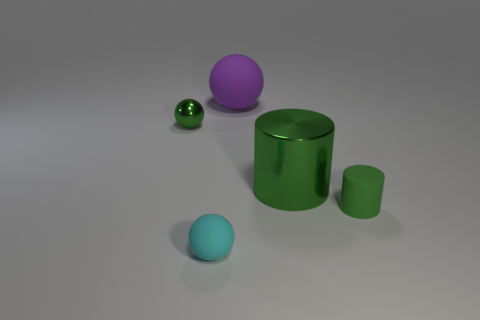What number of small cylinders have the same material as the large green cylinder?
Make the answer very short. 0. What is the color of the large cylinder that is made of the same material as the small green sphere?
Provide a succinct answer. Green. There is a matte ball behind the green metal thing right of the metal thing that is on the left side of the big rubber sphere; how big is it?
Ensure brevity in your answer.  Large. Is the number of green matte cylinders less than the number of green rubber blocks?
Give a very brief answer. No. There is a small metal object that is the same shape as the purple matte object; what is its color?
Give a very brief answer. Green. Is there a matte thing that is right of the sphere behind the metallic thing left of the green metal cylinder?
Your answer should be very brief. Yes. Is the shape of the large green thing the same as the tiny green rubber object?
Provide a succinct answer. Yes. Are there fewer big purple things in front of the large rubber ball than large cyan metallic cylinders?
Give a very brief answer. No. There is a sphere that is to the left of the tiny sphere that is in front of the green object left of the large metal thing; what is its color?
Offer a very short reply. Green. What number of metallic objects are either big cyan blocks or tiny cylinders?
Keep it short and to the point. 0. 